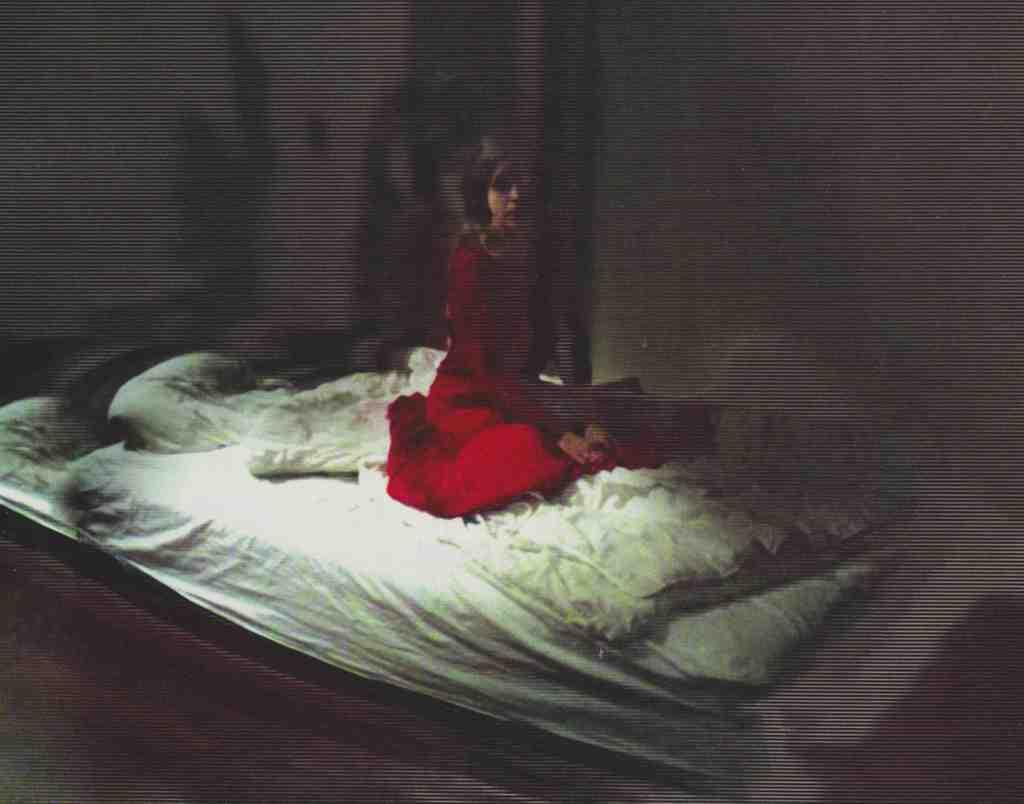Who is present in the image? There is a woman in the image. What is the woman doing in the image? The woman is sitting on a bed. What is the woman wearing in the image? The woman is wearing a red dress. Can you see a tiger in the image? No, there is no tiger present in the image. What type of beetle can be seen crawling on the woman's dress? There is no beetle present in the image; the woman is wearing a red dress. 